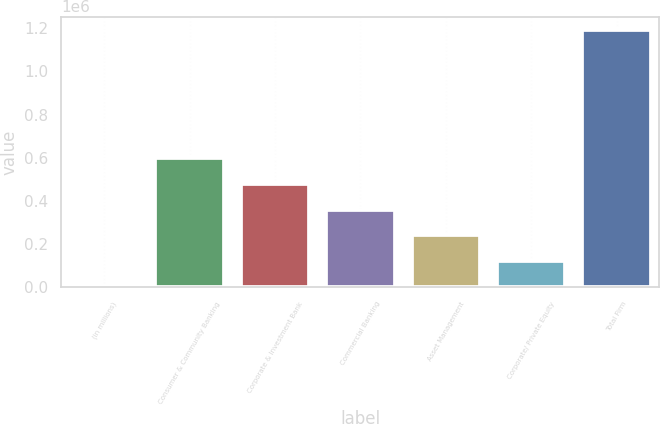<chart> <loc_0><loc_0><loc_500><loc_500><bar_chart><fcel>(in millions)<fcel>Consumer & Community Banking<fcel>Corporate & Investment Bank<fcel>Commercial Banking<fcel>Asset Management<fcel>Corporate/ Private Equity<fcel>Total Firm<nl><fcel>2012<fcel>597802<fcel>478644<fcel>359486<fcel>240328<fcel>121170<fcel>1.19359e+06<nl></chart> 